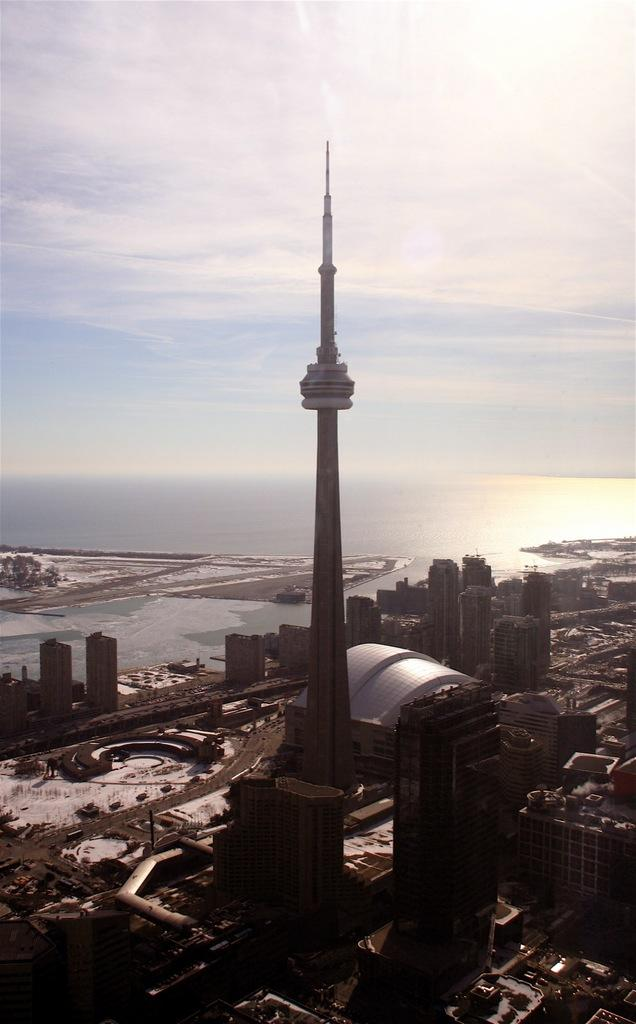What is the main structure in the middle of the image? There is a tower in the middle of the image. What other structures can be seen in the image? There are buildings in the image. What natural feature is visible in the background of the image? There is an ocean in the background of the image. What is visible in the sky in the background of the image? There are clouds in the sky in the background of the image. What type of behavior does the rabbit exhibit in the image? There is no rabbit present in the image, so it is not possible to discuss its behavior. 